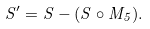Convert formula to latex. <formula><loc_0><loc_0><loc_500><loc_500>S ^ { \prime } = S - ( S \circ M _ { 5 } ) .</formula> 